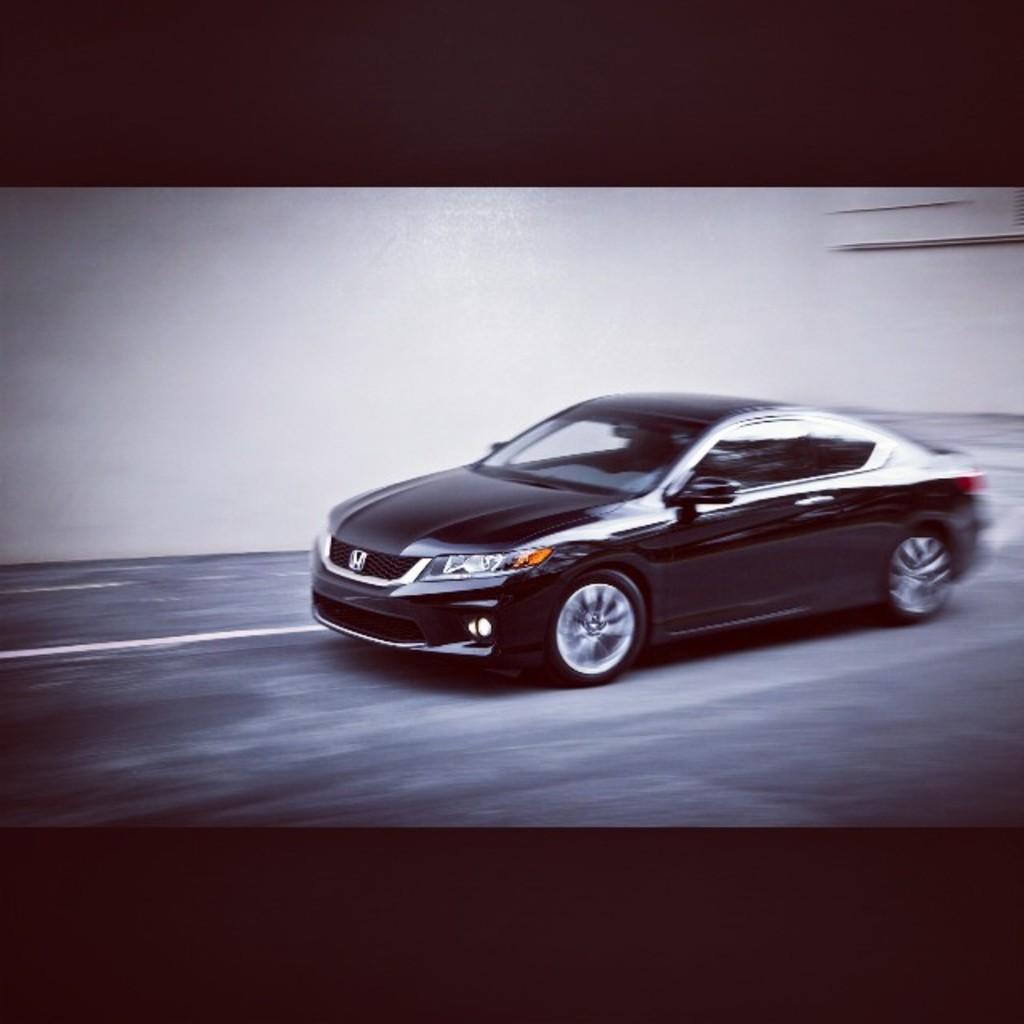In one or two sentences, can you explain what this image depicts? In this image I can see a car which is in black color on the road and background I can see the wall in white color. 